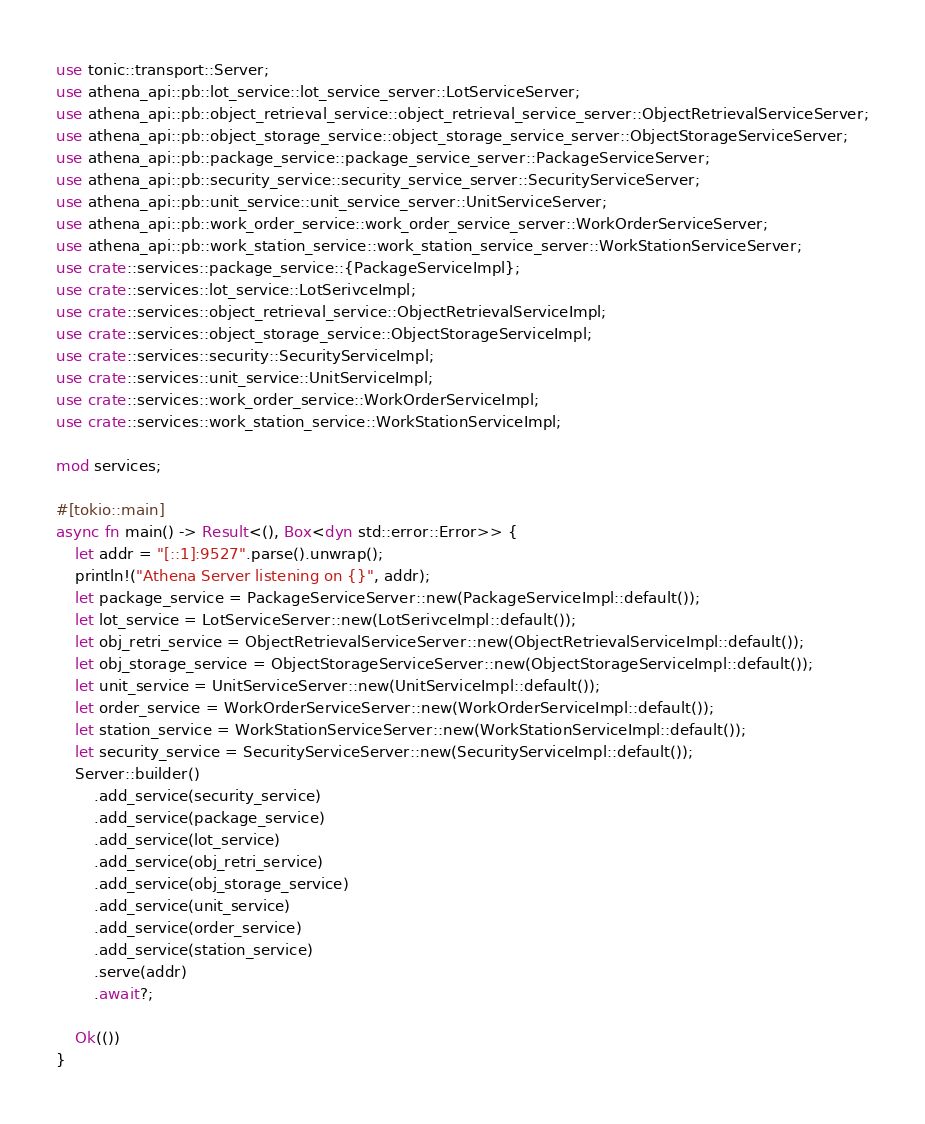<code> <loc_0><loc_0><loc_500><loc_500><_Rust_>use tonic::transport::Server;
use athena_api::pb::lot_service::lot_service_server::LotServiceServer;
use athena_api::pb::object_retrieval_service::object_retrieval_service_server::ObjectRetrievalServiceServer;
use athena_api::pb::object_storage_service::object_storage_service_server::ObjectStorageServiceServer;
use athena_api::pb::package_service::package_service_server::PackageServiceServer;
use athena_api::pb::security_service::security_service_server::SecurityServiceServer;
use athena_api::pb::unit_service::unit_service_server::UnitServiceServer;
use athena_api::pb::work_order_service::work_order_service_server::WorkOrderServiceServer;
use athena_api::pb::work_station_service::work_station_service_server::WorkStationServiceServer;
use crate::services::package_service::{PackageServiceImpl};
use crate::services::lot_service::LotSerivceImpl;
use crate::services::object_retrieval_service::ObjectRetrievalServiceImpl;
use crate::services::object_storage_service::ObjectStorageServiceImpl;
use crate::services::security::SecurityServiceImpl;
use crate::services::unit_service::UnitServiceImpl;
use crate::services::work_order_service::WorkOrderServiceImpl;
use crate::services::work_station_service::WorkStationServiceImpl;

mod services;

#[tokio::main]
async fn main() -> Result<(), Box<dyn std::error::Error>> {
    let addr = "[::1]:9527".parse().unwrap();
    println!("Athena Server listening on {}", addr);
    let package_service = PackageServiceServer::new(PackageServiceImpl::default());
    let lot_service = LotServiceServer::new(LotSerivceImpl::default());
    let obj_retri_service = ObjectRetrievalServiceServer::new(ObjectRetrievalServiceImpl::default());
    let obj_storage_service = ObjectStorageServiceServer::new(ObjectStorageServiceImpl::default());
    let unit_service = UnitServiceServer::new(UnitServiceImpl::default());
    let order_service = WorkOrderServiceServer::new(WorkOrderServiceImpl::default());
    let station_service = WorkStationServiceServer::new(WorkStationServiceImpl::default());
    let security_service = SecurityServiceServer::new(SecurityServiceImpl::default());
    Server::builder()
        .add_service(security_service)
        .add_service(package_service)
        .add_service(lot_service)
        .add_service(obj_retri_service)
        .add_service(obj_storage_service)
        .add_service(unit_service)
        .add_service(order_service)
        .add_service(station_service)
        .serve(addr)
        .await?;

    Ok(())
}
</code> 